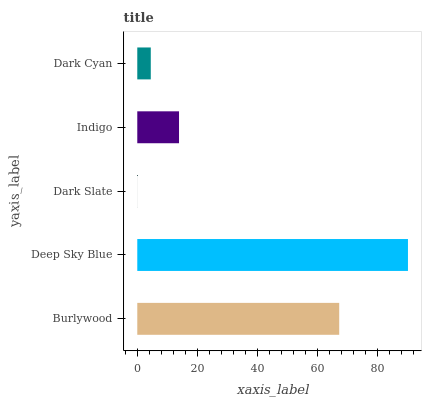Is Dark Slate the minimum?
Answer yes or no. Yes. Is Deep Sky Blue the maximum?
Answer yes or no. Yes. Is Deep Sky Blue the minimum?
Answer yes or no. No. Is Dark Slate the maximum?
Answer yes or no. No. Is Deep Sky Blue greater than Dark Slate?
Answer yes or no. Yes. Is Dark Slate less than Deep Sky Blue?
Answer yes or no. Yes. Is Dark Slate greater than Deep Sky Blue?
Answer yes or no. No. Is Deep Sky Blue less than Dark Slate?
Answer yes or no. No. Is Indigo the high median?
Answer yes or no. Yes. Is Indigo the low median?
Answer yes or no. Yes. Is Dark Slate the high median?
Answer yes or no. No. Is Dark Slate the low median?
Answer yes or no. No. 